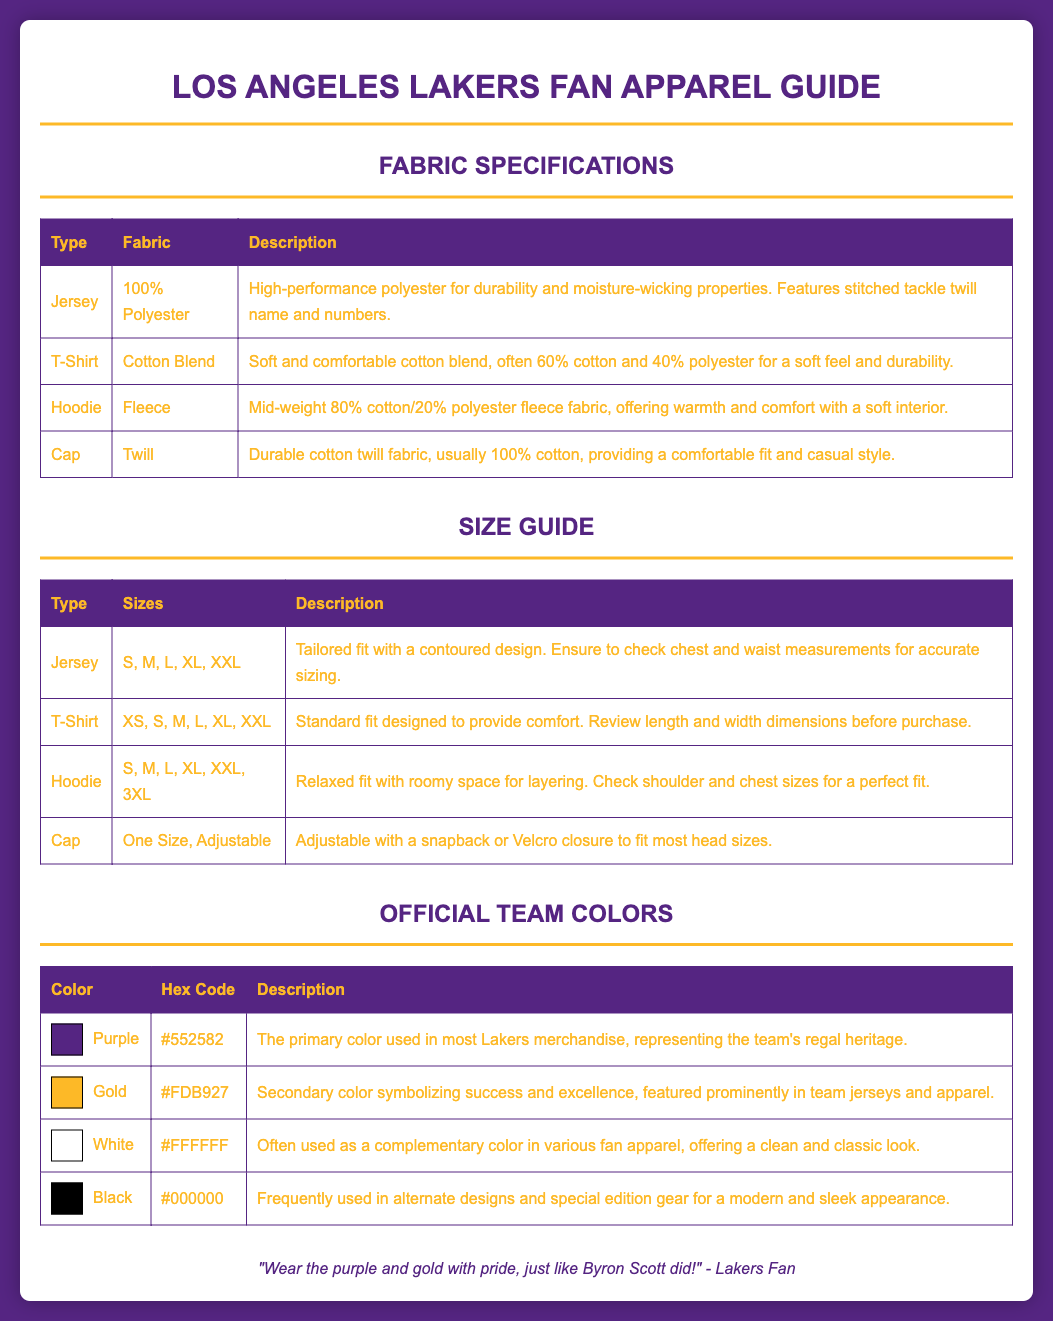What type of fabric is used for a Lakers jersey? The document states that the Lakers jersey is made of 100% polyester, which provides durability and moisture-wicking properties.
Answer: 100% Polyester How many sizes are available for hoodies? The size guide for hoodies indicates that several sizes are available, specifically S, M, L, XL, XXL, and 3XL.
Answer: 6 What is the hex code for the color gold? The document lists the official team colors and specifies that the hex code for gold is #FDB927.
Answer: #FDB927 What is the main description of the t-shirt fabric? The fabric for the t-shirt is described as a soft and comfortable cotton blend, usually 60% cotton and 40% polyester.
Answer: Soft and comfortable cotton blend Which color is used to symbolize the Lakers' royal heritage? According to the document, the purple color represents the team's regal heritage.
Answer: Purple What does the hoodie fabric composition consist of? The document explains that the hoodie is made of a mid-weight fleece fabric, specifically containing 80% cotton and 20% polyester.
Answer: 80% cotton/20% polyester What is the fit style of the jersey? The size guide for jerseys details that they have a tailored fit with a contoured design.
Answer: Tailored fit What closure types are available for the cap? The document states that the cap is adjustable with a snapback or Velcro closure, providing flexibility for different head sizes.
Answer: Snapback or Velcro closure 